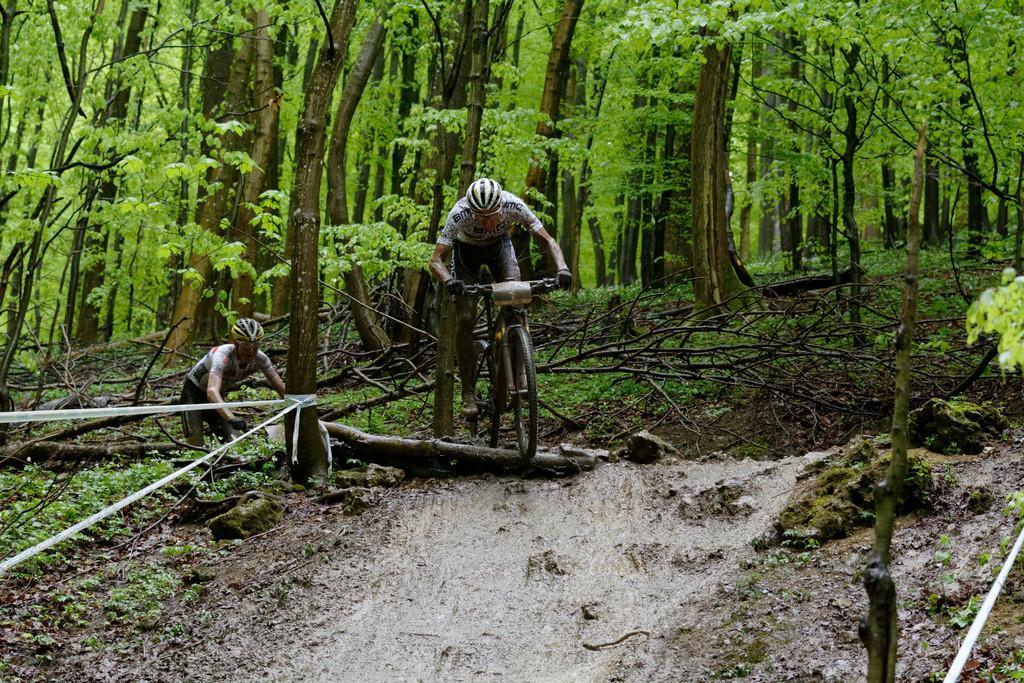Describe this image in one or two sentences. In this image we can a person riding a bicycle. In the background of the image there are trees. At the bottom of the image there is road. 